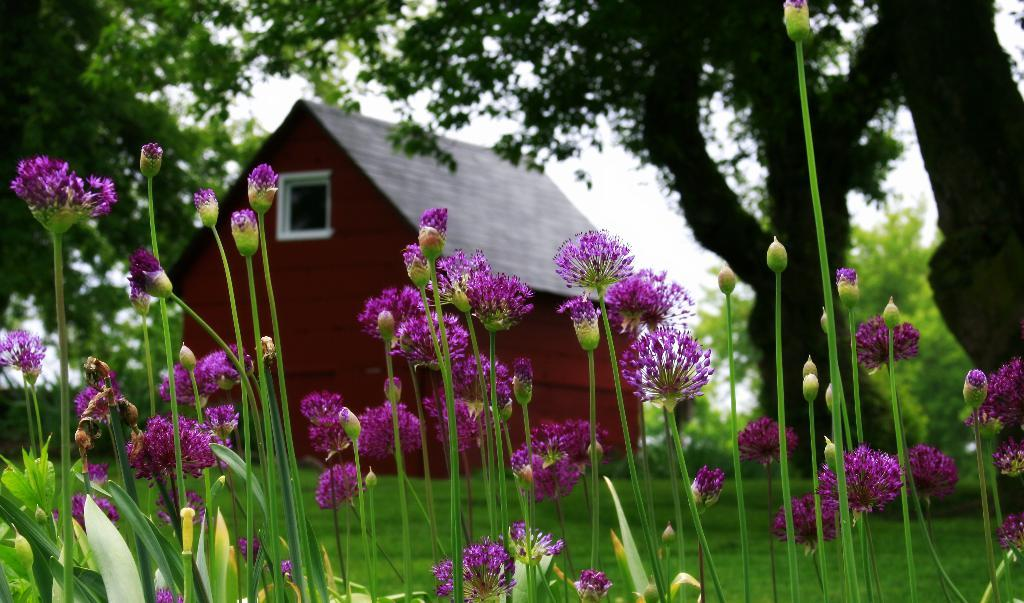What type of flowers can be seen in the foreground of the image? There are violet color flowers in the foreground of the image. What are the flowers growing on? The flowers are on plants. Are there any unopened flowers on the plants? Yes, there are buds on the plants. What can be seen in the background of the image? There is a house, trees, and the sky visible in the background of the image. How many cats are sitting on the roof of the house in the image? There are no cats present in the image, and the roof of the house is not visible. 